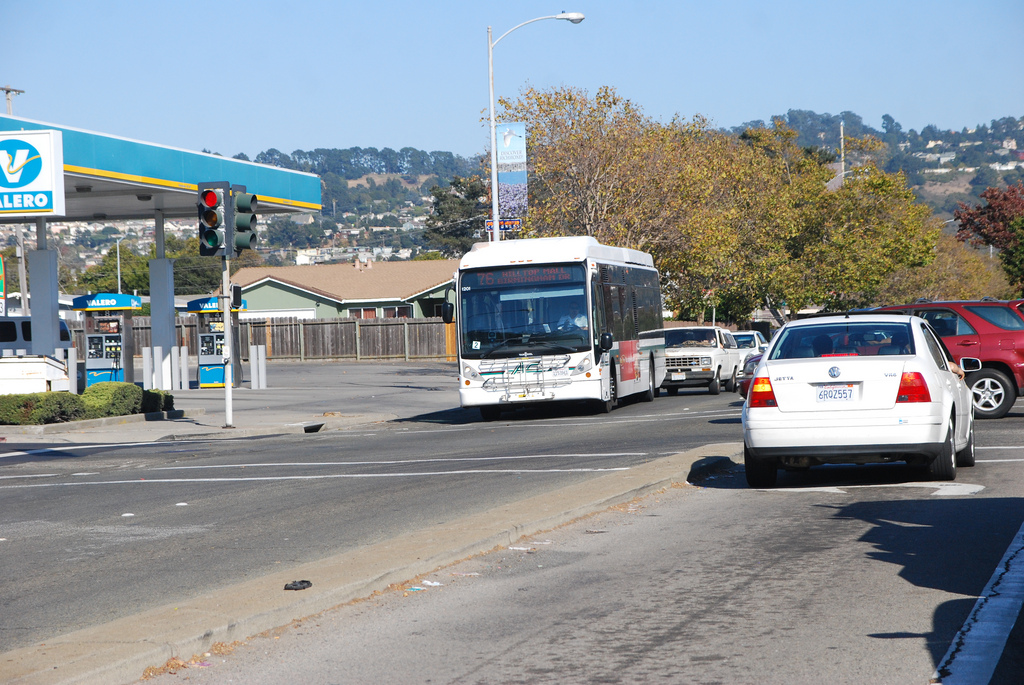Are there any fences to the left of the car on the road? Yes, there is a continuous wooden fence running along the left side of the road, just beside the sidewalk. 